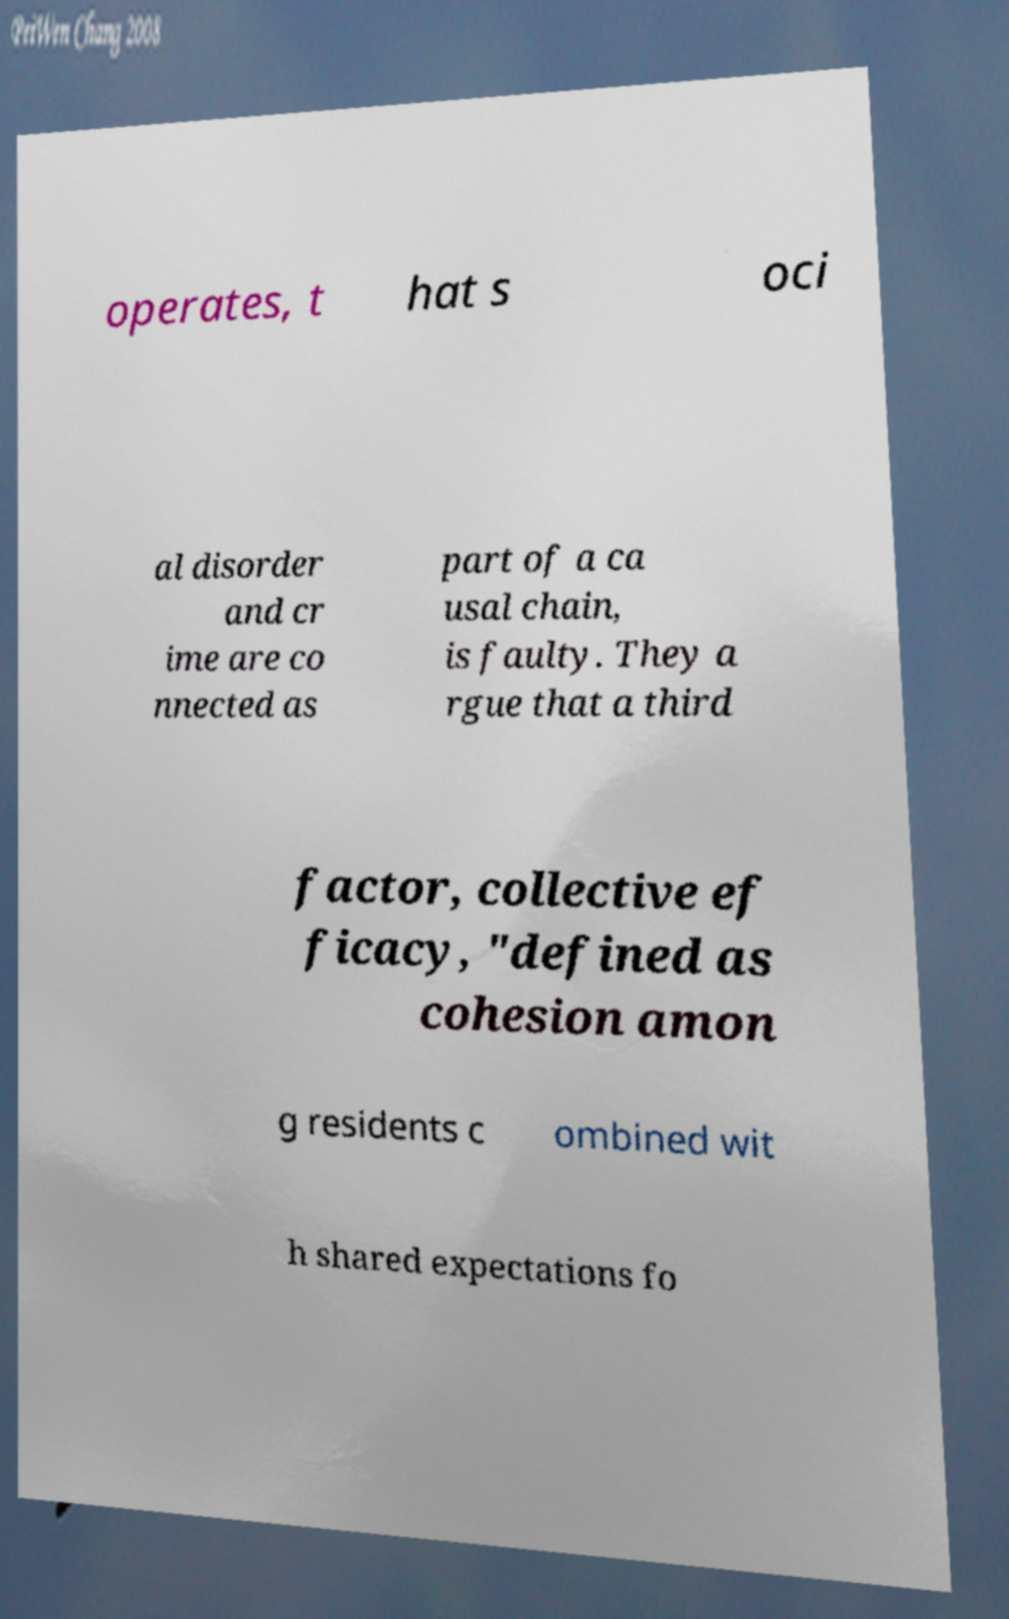There's text embedded in this image that I need extracted. Can you transcribe it verbatim? operates, t hat s oci al disorder and cr ime are co nnected as part of a ca usal chain, is faulty. They a rgue that a third factor, collective ef ficacy, "defined as cohesion amon g residents c ombined wit h shared expectations fo 